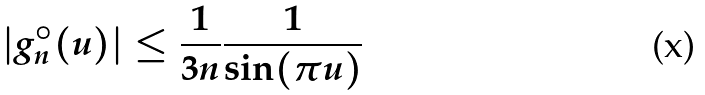Convert formula to latex. <formula><loc_0><loc_0><loc_500><loc_500>| { g } ^ { \circ } _ { n } ( u ) | \leq \frac { 1 } { 3 n } \frac { 1 } { \sin ( \pi u ) }</formula> 